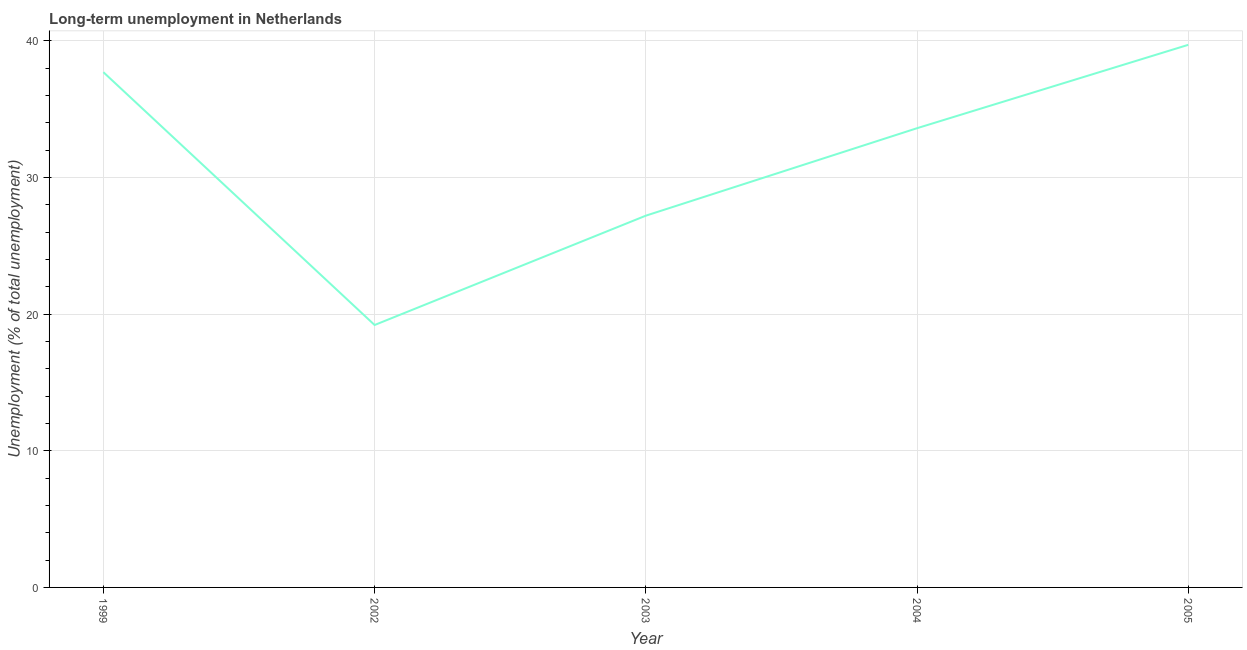What is the long-term unemployment in 2003?
Provide a short and direct response. 27.2. Across all years, what is the maximum long-term unemployment?
Provide a succinct answer. 39.7. Across all years, what is the minimum long-term unemployment?
Offer a terse response. 19.2. In which year was the long-term unemployment maximum?
Make the answer very short. 2005. What is the sum of the long-term unemployment?
Your answer should be very brief. 157.4. What is the difference between the long-term unemployment in 2003 and 2004?
Provide a succinct answer. -6.4. What is the average long-term unemployment per year?
Make the answer very short. 31.48. What is the median long-term unemployment?
Your response must be concise. 33.6. In how many years, is the long-term unemployment greater than 26 %?
Ensure brevity in your answer.  4. Do a majority of the years between 1999 and 2005 (inclusive) have long-term unemployment greater than 26 %?
Provide a short and direct response. Yes. What is the ratio of the long-term unemployment in 1999 to that in 2005?
Your answer should be very brief. 0.95. What is the difference between the highest and the second highest long-term unemployment?
Give a very brief answer. 2. What is the difference between the highest and the lowest long-term unemployment?
Make the answer very short. 20.5. How many lines are there?
Your answer should be compact. 1. How many years are there in the graph?
Your response must be concise. 5. What is the difference between two consecutive major ticks on the Y-axis?
Your answer should be very brief. 10. What is the title of the graph?
Your response must be concise. Long-term unemployment in Netherlands. What is the label or title of the Y-axis?
Ensure brevity in your answer.  Unemployment (% of total unemployment). What is the Unemployment (% of total unemployment) of 1999?
Make the answer very short. 37.7. What is the Unemployment (% of total unemployment) in 2002?
Provide a succinct answer. 19.2. What is the Unemployment (% of total unemployment) in 2003?
Ensure brevity in your answer.  27.2. What is the Unemployment (% of total unemployment) in 2004?
Give a very brief answer. 33.6. What is the Unemployment (% of total unemployment) of 2005?
Your answer should be compact. 39.7. What is the difference between the Unemployment (% of total unemployment) in 1999 and 2003?
Your answer should be compact. 10.5. What is the difference between the Unemployment (% of total unemployment) in 1999 and 2004?
Ensure brevity in your answer.  4.1. What is the difference between the Unemployment (% of total unemployment) in 2002 and 2004?
Make the answer very short. -14.4. What is the difference between the Unemployment (% of total unemployment) in 2002 and 2005?
Provide a succinct answer. -20.5. What is the difference between the Unemployment (% of total unemployment) in 2003 and 2004?
Provide a short and direct response. -6.4. What is the difference between the Unemployment (% of total unemployment) in 2003 and 2005?
Provide a short and direct response. -12.5. What is the difference between the Unemployment (% of total unemployment) in 2004 and 2005?
Make the answer very short. -6.1. What is the ratio of the Unemployment (% of total unemployment) in 1999 to that in 2002?
Your response must be concise. 1.96. What is the ratio of the Unemployment (% of total unemployment) in 1999 to that in 2003?
Give a very brief answer. 1.39. What is the ratio of the Unemployment (% of total unemployment) in 1999 to that in 2004?
Provide a short and direct response. 1.12. What is the ratio of the Unemployment (% of total unemployment) in 1999 to that in 2005?
Provide a succinct answer. 0.95. What is the ratio of the Unemployment (% of total unemployment) in 2002 to that in 2003?
Offer a terse response. 0.71. What is the ratio of the Unemployment (% of total unemployment) in 2002 to that in 2004?
Offer a terse response. 0.57. What is the ratio of the Unemployment (% of total unemployment) in 2002 to that in 2005?
Your answer should be very brief. 0.48. What is the ratio of the Unemployment (% of total unemployment) in 2003 to that in 2004?
Your answer should be compact. 0.81. What is the ratio of the Unemployment (% of total unemployment) in 2003 to that in 2005?
Provide a short and direct response. 0.69. What is the ratio of the Unemployment (% of total unemployment) in 2004 to that in 2005?
Your response must be concise. 0.85. 